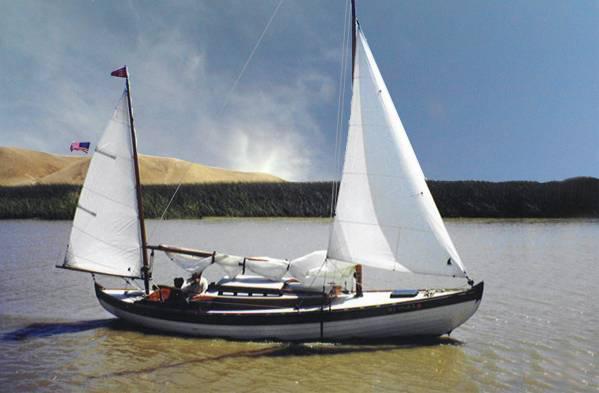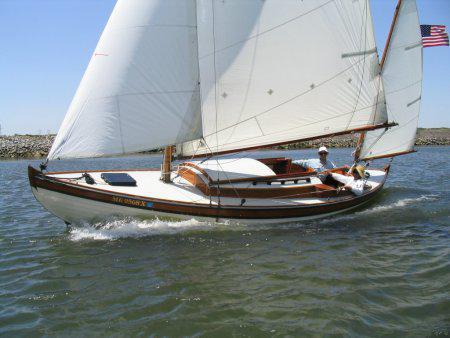The first image is the image on the left, the second image is the image on the right. For the images displayed, is the sentence "An image shows a white-sailed boat creating white spray as it moves through the water." factually correct? Answer yes or no. Yes. The first image is the image on the left, the second image is the image on the right. Assess this claim about the two images: "There is a docked boat in the water whos sail is not deployed.". Correct or not? Answer yes or no. No. 